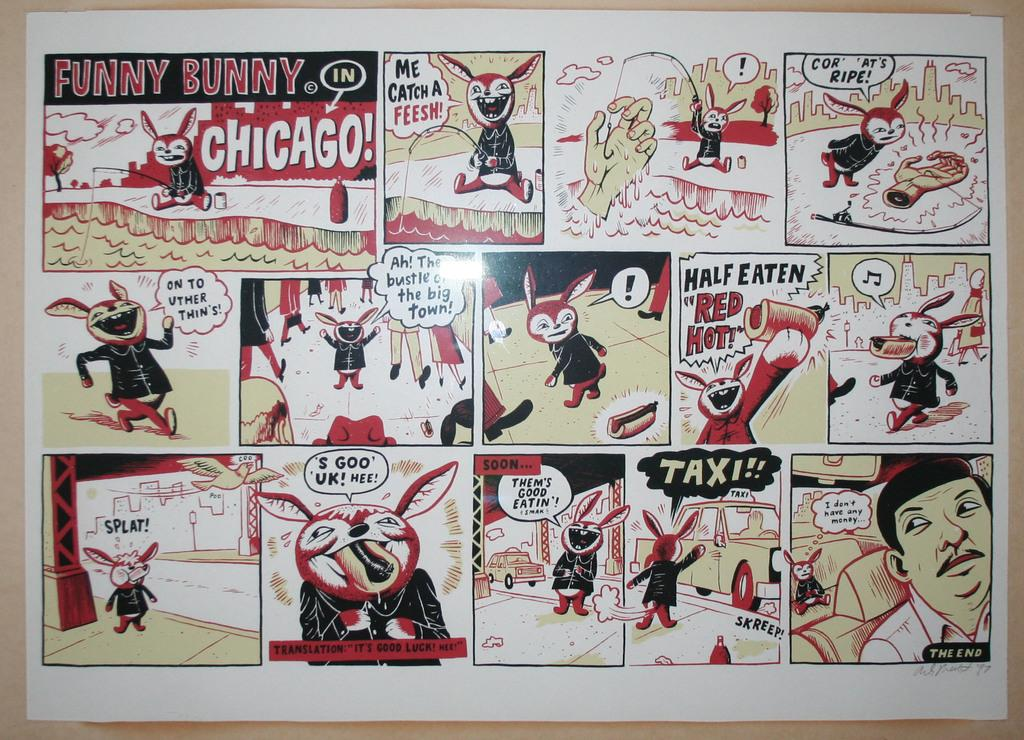<image>
Write a terse but informative summary of the picture. A comic strip depicts Funny Bunny in Chicago. 